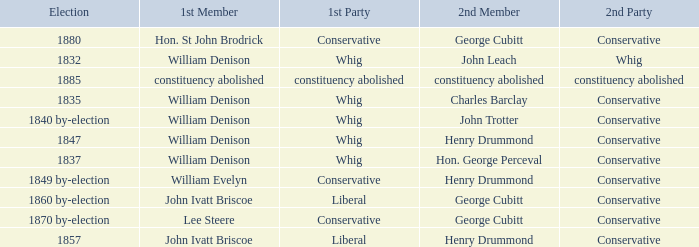Which party with an 1835 election has 1st member William Denison? Conservative. 